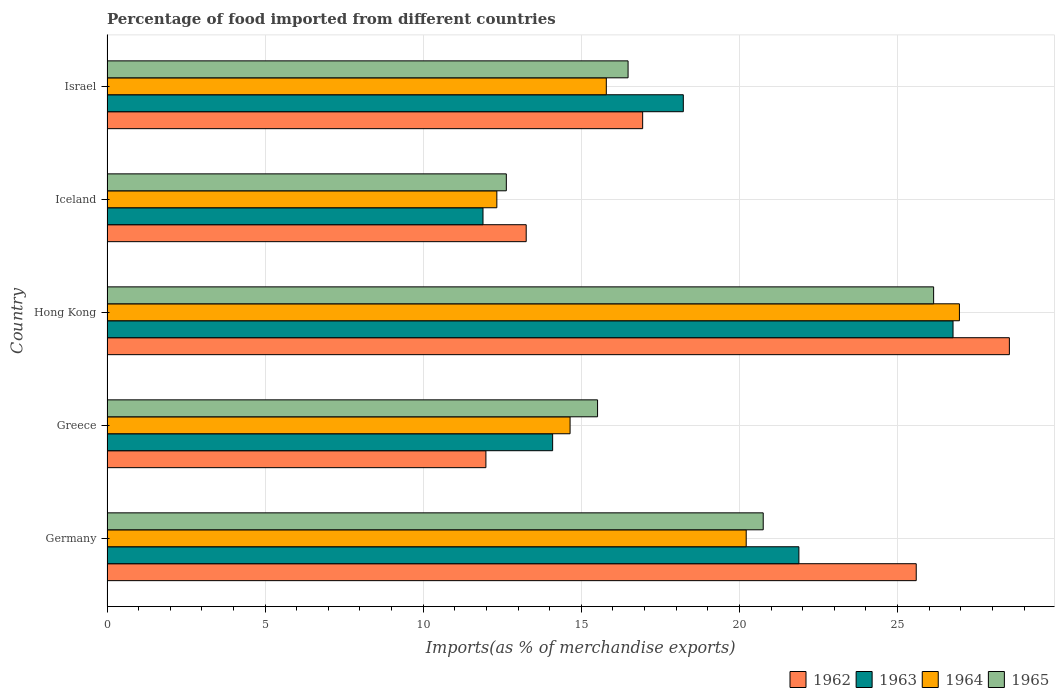How many groups of bars are there?
Offer a very short reply. 5. Are the number of bars per tick equal to the number of legend labels?
Offer a very short reply. Yes. What is the label of the 4th group of bars from the top?
Provide a short and direct response. Greece. In how many cases, is the number of bars for a given country not equal to the number of legend labels?
Ensure brevity in your answer.  0. What is the percentage of imports to different countries in 1964 in Greece?
Keep it short and to the point. 14.64. Across all countries, what is the maximum percentage of imports to different countries in 1962?
Your answer should be very brief. 28.53. Across all countries, what is the minimum percentage of imports to different countries in 1965?
Offer a very short reply. 12.63. In which country was the percentage of imports to different countries in 1964 maximum?
Ensure brevity in your answer.  Hong Kong. In which country was the percentage of imports to different countries in 1965 minimum?
Keep it short and to the point. Iceland. What is the total percentage of imports to different countries in 1962 in the graph?
Provide a succinct answer. 96.3. What is the difference between the percentage of imports to different countries in 1963 in Germany and that in Hong Kong?
Offer a terse response. -4.87. What is the difference between the percentage of imports to different countries in 1963 in Greece and the percentage of imports to different countries in 1965 in Israel?
Make the answer very short. -2.39. What is the average percentage of imports to different countries in 1965 per country?
Provide a short and direct response. 18.3. What is the difference between the percentage of imports to different countries in 1963 and percentage of imports to different countries in 1964 in Hong Kong?
Your answer should be compact. -0.2. What is the ratio of the percentage of imports to different countries in 1964 in Greece to that in Iceland?
Your answer should be very brief. 1.19. What is the difference between the highest and the second highest percentage of imports to different countries in 1963?
Your answer should be compact. 4.87. What is the difference between the highest and the lowest percentage of imports to different countries in 1962?
Your answer should be compact. 16.55. Is the sum of the percentage of imports to different countries in 1962 in Germany and Greece greater than the maximum percentage of imports to different countries in 1964 across all countries?
Ensure brevity in your answer.  Yes. Is it the case that in every country, the sum of the percentage of imports to different countries in 1965 and percentage of imports to different countries in 1963 is greater than the sum of percentage of imports to different countries in 1964 and percentage of imports to different countries in 1962?
Keep it short and to the point. No. What does the 2nd bar from the top in Hong Kong represents?
Offer a very short reply. 1964. What does the 3rd bar from the bottom in Iceland represents?
Offer a terse response. 1964. Are all the bars in the graph horizontal?
Your answer should be very brief. Yes. How many countries are there in the graph?
Offer a very short reply. 5. What is the difference between two consecutive major ticks on the X-axis?
Offer a terse response. 5. Does the graph contain grids?
Give a very brief answer. Yes. How many legend labels are there?
Offer a terse response. 4. What is the title of the graph?
Make the answer very short. Percentage of food imported from different countries. What is the label or title of the X-axis?
Your response must be concise. Imports(as % of merchandise exports). What is the label or title of the Y-axis?
Provide a succinct answer. Country. What is the Imports(as % of merchandise exports) in 1962 in Germany?
Provide a short and direct response. 25.59. What is the Imports(as % of merchandise exports) of 1963 in Germany?
Ensure brevity in your answer.  21.88. What is the Imports(as % of merchandise exports) of 1964 in Germany?
Keep it short and to the point. 20.21. What is the Imports(as % of merchandise exports) of 1965 in Germany?
Offer a terse response. 20.75. What is the Imports(as % of merchandise exports) in 1962 in Greece?
Your answer should be compact. 11.98. What is the Imports(as % of merchandise exports) in 1963 in Greece?
Keep it short and to the point. 14.09. What is the Imports(as % of merchandise exports) in 1964 in Greece?
Your answer should be compact. 14.64. What is the Imports(as % of merchandise exports) in 1965 in Greece?
Your answer should be compact. 15.51. What is the Imports(as % of merchandise exports) of 1962 in Hong Kong?
Provide a succinct answer. 28.53. What is the Imports(as % of merchandise exports) of 1963 in Hong Kong?
Your answer should be very brief. 26.75. What is the Imports(as % of merchandise exports) of 1964 in Hong Kong?
Provide a succinct answer. 26.96. What is the Imports(as % of merchandise exports) in 1965 in Hong Kong?
Your answer should be compact. 26.14. What is the Imports(as % of merchandise exports) of 1962 in Iceland?
Provide a succinct answer. 13.26. What is the Imports(as % of merchandise exports) in 1963 in Iceland?
Ensure brevity in your answer.  11.89. What is the Imports(as % of merchandise exports) of 1964 in Iceland?
Keep it short and to the point. 12.33. What is the Imports(as % of merchandise exports) of 1965 in Iceland?
Offer a very short reply. 12.63. What is the Imports(as % of merchandise exports) in 1962 in Israel?
Your answer should be compact. 16.94. What is the Imports(as % of merchandise exports) of 1963 in Israel?
Offer a very short reply. 18.22. What is the Imports(as % of merchandise exports) in 1964 in Israel?
Give a very brief answer. 15.79. What is the Imports(as % of merchandise exports) of 1965 in Israel?
Your answer should be compact. 16.48. Across all countries, what is the maximum Imports(as % of merchandise exports) of 1962?
Ensure brevity in your answer.  28.53. Across all countries, what is the maximum Imports(as % of merchandise exports) of 1963?
Offer a terse response. 26.75. Across all countries, what is the maximum Imports(as % of merchandise exports) in 1964?
Your answer should be compact. 26.96. Across all countries, what is the maximum Imports(as % of merchandise exports) of 1965?
Offer a very short reply. 26.14. Across all countries, what is the minimum Imports(as % of merchandise exports) in 1962?
Ensure brevity in your answer.  11.98. Across all countries, what is the minimum Imports(as % of merchandise exports) in 1963?
Make the answer very short. 11.89. Across all countries, what is the minimum Imports(as % of merchandise exports) in 1964?
Give a very brief answer. 12.33. Across all countries, what is the minimum Imports(as % of merchandise exports) of 1965?
Ensure brevity in your answer.  12.63. What is the total Imports(as % of merchandise exports) of 1962 in the graph?
Provide a short and direct response. 96.3. What is the total Imports(as % of merchandise exports) of 1963 in the graph?
Provide a short and direct response. 92.84. What is the total Imports(as % of merchandise exports) in 1964 in the graph?
Your answer should be compact. 89.93. What is the total Imports(as % of merchandise exports) in 1965 in the graph?
Provide a succinct answer. 91.51. What is the difference between the Imports(as % of merchandise exports) in 1962 in Germany and that in Greece?
Your answer should be compact. 13.61. What is the difference between the Imports(as % of merchandise exports) of 1963 in Germany and that in Greece?
Offer a very short reply. 7.79. What is the difference between the Imports(as % of merchandise exports) in 1964 in Germany and that in Greece?
Offer a very short reply. 5.57. What is the difference between the Imports(as % of merchandise exports) of 1965 in Germany and that in Greece?
Your answer should be compact. 5.24. What is the difference between the Imports(as % of merchandise exports) of 1962 in Germany and that in Hong Kong?
Provide a succinct answer. -2.95. What is the difference between the Imports(as % of merchandise exports) in 1963 in Germany and that in Hong Kong?
Provide a short and direct response. -4.87. What is the difference between the Imports(as % of merchandise exports) in 1964 in Germany and that in Hong Kong?
Your response must be concise. -6.74. What is the difference between the Imports(as % of merchandise exports) in 1965 in Germany and that in Hong Kong?
Your response must be concise. -5.39. What is the difference between the Imports(as % of merchandise exports) in 1962 in Germany and that in Iceland?
Your response must be concise. 12.33. What is the difference between the Imports(as % of merchandise exports) of 1963 in Germany and that in Iceland?
Offer a very short reply. 9.99. What is the difference between the Imports(as % of merchandise exports) of 1964 in Germany and that in Iceland?
Offer a very short reply. 7.89. What is the difference between the Imports(as % of merchandise exports) in 1965 in Germany and that in Iceland?
Offer a very short reply. 8.12. What is the difference between the Imports(as % of merchandise exports) in 1962 in Germany and that in Israel?
Keep it short and to the point. 8.65. What is the difference between the Imports(as % of merchandise exports) of 1963 in Germany and that in Israel?
Your response must be concise. 3.65. What is the difference between the Imports(as % of merchandise exports) in 1964 in Germany and that in Israel?
Give a very brief answer. 4.42. What is the difference between the Imports(as % of merchandise exports) of 1965 in Germany and that in Israel?
Provide a short and direct response. 4.27. What is the difference between the Imports(as % of merchandise exports) of 1962 in Greece and that in Hong Kong?
Offer a terse response. -16.55. What is the difference between the Imports(as % of merchandise exports) of 1963 in Greece and that in Hong Kong?
Ensure brevity in your answer.  -12.66. What is the difference between the Imports(as % of merchandise exports) in 1964 in Greece and that in Hong Kong?
Provide a short and direct response. -12.31. What is the difference between the Imports(as % of merchandise exports) in 1965 in Greece and that in Hong Kong?
Keep it short and to the point. -10.63. What is the difference between the Imports(as % of merchandise exports) in 1962 in Greece and that in Iceland?
Your answer should be very brief. -1.27. What is the difference between the Imports(as % of merchandise exports) of 1963 in Greece and that in Iceland?
Offer a very short reply. 2.2. What is the difference between the Imports(as % of merchandise exports) in 1964 in Greece and that in Iceland?
Your response must be concise. 2.32. What is the difference between the Imports(as % of merchandise exports) of 1965 in Greece and that in Iceland?
Offer a terse response. 2.88. What is the difference between the Imports(as % of merchandise exports) in 1962 in Greece and that in Israel?
Offer a terse response. -4.96. What is the difference between the Imports(as % of merchandise exports) of 1963 in Greece and that in Israel?
Give a very brief answer. -4.13. What is the difference between the Imports(as % of merchandise exports) of 1964 in Greece and that in Israel?
Provide a succinct answer. -1.15. What is the difference between the Imports(as % of merchandise exports) of 1965 in Greece and that in Israel?
Keep it short and to the point. -0.97. What is the difference between the Imports(as % of merchandise exports) in 1962 in Hong Kong and that in Iceland?
Your answer should be compact. 15.28. What is the difference between the Imports(as % of merchandise exports) of 1963 in Hong Kong and that in Iceland?
Make the answer very short. 14.86. What is the difference between the Imports(as % of merchandise exports) of 1964 in Hong Kong and that in Iceland?
Offer a very short reply. 14.63. What is the difference between the Imports(as % of merchandise exports) in 1965 in Hong Kong and that in Iceland?
Your answer should be compact. 13.51. What is the difference between the Imports(as % of merchandise exports) in 1962 in Hong Kong and that in Israel?
Your response must be concise. 11.6. What is the difference between the Imports(as % of merchandise exports) in 1963 in Hong Kong and that in Israel?
Offer a very short reply. 8.53. What is the difference between the Imports(as % of merchandise exports) of 1964 in Hong Kong and that in Israel?
Offer a very short reply. 11.17. What is the difference between the Imports(as % of merchandise exports) of 1965 in Hong Kong and that in Israel?
Offer a very short reply. 9.66. What is the difference between the Imports(as % of merchandise exports) in 1962 in Iceland and that in Israel?
Offer a terse response. -3.68. What is the difference between the Imports(as % of merchandise exports) of 1963 in Iceland and that in Israel?
Offer a terse response. -6.33. What is the difference between the Imports(as % of merchandise exports) in 1964 in Iceland and that in Israel?
Offer a very short reply. -3.46. What is the difference between the Imports(as % of merchandise exports) in 1965 in Iceland and that in Israel?
Offer a very short reply. -3.85. What is the difference between the Imports(as % of merchandise exports) in 1962 in Germany and the Imports(as % of merchandise exports) in 1963 in Greece?
Make the answer very short. 11.5. What is the difference between the Imports(as % of merchandise exports) in 1962 in Germany and the Imports(as % of merchandise exports) in 1964 in Greece?
Your response must be concise. 10.95. What is the difference between the Imports(as % of merchandise exports) in 1962 in Germany and the Imports(as % of merchandise exports) in 1965 in Greece?
Provide a short and direct response. 10.08. What is the difference between the Imports(as % of merchandise exports) of 1963 in Germany and the Imports(as % of merchandise exports) of 1964 in Greece?
Provide a short and direct response. 7.24. What is the difference between the Imports(as % of merchandise exports) of 1963 in Germany and the Imports(as % of merchandise exports) of 1965 in Greece?
Offer a terse response. 6.37. What is the difference between the Imports(as % of merchandise exports) in 1964 in Germany and the Imports(as % of merchandise exports) in 1965 in Greece?
Keep it short and to the point. 4.7. What is the difference between the Imports(as % of merchandise exports) in 1962 in Germany and the Imports(as % of merchandise exports) in 1963 in Hong Kong?
Provide a succinct answer. -1.16. What is the difference between the Imports(as % of merchandise exports) of 1962 in Germany and the Imports(as % of merchandise exports) of 1964 in Hong Kong?
Offer a terse response. -1.37. What is the difference between the Imports(as % of merchandise exports) in 1962 in Germany and the Imports(as % of merchandise exports) in 1965 in Hong Kong?
Give a very brief answer. -0.55. What is the difference between the Imports(as % of merchandise exports) in 1963 in Germany and the Imports(as % of merchandise exports) in 1964 in Hong Kong?
Keep it short and to the point. -5.08. What is the difference between the Imports(as % of merchandise exports) in 1963 in Germany and the Imports(as % of merchandise exports) in 1965 in Hong Kong?
Offer a very short reply. -4.26. What is the difference between the Imports(as % of merchandise exports) in 1964 in Germany and the Imports(as % of merchandise exports) in 1965 in Hong Kong?
Make the answer very short. -5.93. What is the difference between the Imports(as % of merchandise exports) in 1962 in Germany and the Imports(as % of merchandise exports) in 1963 in Iceland?
Provide a succinct answer. 13.7. What is the difference between the Imports(as % of merchandise exports) of 1962 in Germany and the Imports(as % of merchandise exports) of 1964 in Iceland?
Ensure brevity in your answer.  13.26. What is the difference between the Imports(as % of merchandise exports) in 1962 in Germany and the Imports(as % of merchandise exports) in 1965 in Iceland?
Offer a very short reply. 12.96. What is the difference between the Imports(as % of merchandise exports) of 1963 in Germany and the Imports(as % of merchandise exports) of 1964 in Iceland?
Your answer should be compact. 9.55. What is the difference between the Imports(as % of merchandise exports) in 1963 in Germany and the Imports(as % of merchandise exports) in 1965 in Iceland?
Ensure brevity in your answer.  9.25. What is the difference between the Imports(as % of merchandise exports) of 1964 in Germany and the Imports(as % of merchandise exports) of 1965 in Iceland?
Provide a short and direct response. 7.59. What is the difference between the Imports(as % of merchandise exports) in 1962 in Germany and the Imports(as % of merchandise exports) in 1963 in Israel?
Provide a succinct answer. 7.37. What is the difference between the Imports(as % of merchandise exports) of 1962 in Germany and the Imports(as % of merchandise exports) of 1964 in Israel?
Keep it short and to the point. 9.8. What is the difference between the Imports(as % of merchandise exports) of 1962 in Germany and the Imports(as % of merchandise exports) of 1965 in Israel?
Your answer should be compact. 9.11. What is the difference between the Imports(as % of merchandise exports) of 1963 in Germany and the Imports(as % of merchandise exports) of 1964 in Israel?
Offer a terse response. 6.09. What is the difference between the Imports(as % of merchandise exports) in 1963 in Germany and the Imports(as % of merchandise exports) in 1965 in Israel?
Your answer should be compact. 5.4. What is the difference between the Imports(as % of merchandise exports) in 1964 in Germany and the Imports(as % of merchandise exports) in 1965 in Israel?
Offer a very short reply. 3.74. What is the difference between the Imports(as % of merchandise exports) in 1962 in Greece and the Imports(as % of merchandise exports) in 1963 in Hong Kong?
Keep it short and to the point. -14.77. What is the difference between the Imports(as % of merchandise exports) of 1962 in Greece and the Imports(as % of merchandise exports) of 1964 in Hong Kong?
Your answer should be very brief. -14.97. What is the difference between the Imports(as % of merchandise exports) in 1962 in Greece and the Imports(as % of merchandise exports) in 1965 in Hong Kong?
Provide a succinct answer. -14.16. What is the difference between the Imports(as % of merchandise exports) of 1963 in Greece and the Imports(as % of merchandise exports) of 1964 in Hong Kong?
Your answer should be very brief. -12.86. What is the difference between the Imports(as % of merchandise exports) in 1963 in Greece and the Imports(as % of merchandise exports) in 1965 in Hong Kong?
Give a very brief answer. -12.05. What is the difference between the Imports(as % of merchandise exports) in 1964 in Greece and the Imports(as % of merchandise exports) in 1965 in Hong Kong?
Provide a succinct answer. -11.5. What is the difference between the Imports(as % of merchandise exports) in 1962 in Greece and the Imports(as % of merchandise exports) in 1963 in Iceland?
Ensure brevity in your answer.  0.09. What is the difference between the Imports(as % of merchandise exports) of 1962 in Greece and the Imports(as % of merchandise exports) of 1964 in Iceland?
Make the answer very short. -0.35. What is the difference between the Imports(as % of merchandise exports) in 1962 in Greece and the Imports(as % of merchandise exports) in 1965 in Iceland?
Provide a short and direct response. -0.65. What is the difference between the Imports(as % of merchandise exports) in 1963 in Greece and the Imports(as % of merchandise exports) in 1964 in Iceland?
Offer a very short reply. 1.76. What is the difference between the Imports(as % of merchandise exports) of 1963 in Greece and the Imports(as % of merchandise exports) of 1965 in Iceland?
Provide a succinct answer. 1.46. What is the difference between the Imports(as % of merchandise exports) of 1964 in Greece and the Imports(as % of merchandise exports) of 1965 in Iceland?
Your answer should be compact. 2.02. What is the difference between the Imports(as % of merchandise exports) of 1962 in Greece and the Imports(as % of merchandise exports) of 1963 in Israel?
Your answer should be very brief. -6.24. What is the difference between the Imports(as % of merchandise exports) of 1962 in Greece and the Imports(as % of merchandise exports) of 1964 in Israel?
Your answer should be compact. -3.81. What is the difference between the Imports(as % of merchandise exports) in 1962 in Greece and the Imports(as % of merchandise exports) in 1965 in Israel?
Offer a very short reply. -4.5. What is the difference between the Imports(as % of merchandise exports) in 1963 in Greece and the Imports(as % of merchandise exports) in 1964 in Israel?
Offer a terse response. -1.7. What is the difference between the Imports(as % of merchandise exports) in 1963 in Greece and the Imports(as % of merchandise exports) in 1965 in Israel?
Your answer should be very brief. -2.39. What is the difference between the Imports(as % of merchandise exports) in 1964 in Greece and the Imports(as % of merchandise exports) in 1965 in Israel?
Offer a terse response. -1.83. What is the difference between the Imports(as % of merchandise exports) of 1962 in Hong Kong and the Imports(as % of merchandise exports) of 1963 in Iceland?
Offer a very short reply. 16.65. What is the difference between the Imports(as % of merchandise exports) in 1962 in Hong Kong and the Imports(as % of merchandise exports) in 1964 in Iceland?
Make the answer very short. 16.21. What is the difference between the Imports(as % of merchandise exports) in 1962 in Hong Kong and the Imports(as % of merchandise exports) in 1965 in Iceland?
Keep it short and to the point. 15.91. What is the difference between the Imports(as % of merchandise exports) in 1963 in Hong Kong and the Imports(as % of merchandise exports) in 1964 in Iceland?
Keep it short and to the point. 14.43. What is the difference between the Imports(as % of merchandise exports) of 1963 in Hong Kong and the Imports(as % of merchandise exports) of 1965 in Iceland?
Provide a succinct answer. 14.13. What is the difference between the Imports(as % of merchandise exports) in 1964 in Hong Kong and the Imports(as % of merchandise exports) in 1965 in Iceland?
Provide a short and direct response. 14.33. What is the difference between the Imports(as % of merchandise exports) in 1962 in Hong Kong and the Imports(as % of merchandise exports) in 1963 in Israel?
Keep it short and to the point. 10.31. What is the difference between the Imports(as % of merchandise exports) in 1962 in Hong Kong and the Imports(as % of merchandise exports) in 1964 in Israel?
Give a very brief answer. 12.75. What is the difference between the Imports(as % of merchandise exports) of 1962 in Hong Kong and the Imports(as % of merchandise exports) of 1965 in Israel?
Offer a terse response. 12.06. What is the difference between the Imports(as % of merchandise exports) in 1963 in Hong Kong and the Imports(as % of merchandise exports) in 1964 in Israel?
Your answer should be compact. 10.96. What is the difference between the Imports(as % of merchandise exports) in 1963 in Hong Kong and the Imports(as % of merchandise exports) in 1965 in Israel?
Offer a terse response. 10.28. What is the difference between the Imports(as % of merchandise exports) in 1964 in Hong Kong and the Imports(as % of merchandise exports) in 1965 in Israel?
Ensure brevity in your answer.  10.48. What is the difference between the Imports(as % of merchandise exports) in 1962 in Iceland and the Imports(as % of merchandise exports) in 1963 in Israel?
Offer a very short reply. -4.97. What is the difference between the Imports(as % of merchandise exports) in 1962 in Iceland and the Imports(as % of merchandise exports) in 1964 in Israel?
Offer a terse response. -2.53. What is the difference between the Imports(as % of merchandise exports) of 1962 in Iceland and the Imports(as % of merchandise exports) of 1965 in Israel?
Offer a terse response. -3.22. What is the difference between the Imports(as % of merchandise exports) of 1963 in Iceland and the Imports(as % of merchandise exports) of 1964 in Israel?
Keep it short and to the point. -3.9. What is the difference between the Imports(as % of merchandise exports) in 1963 in Iceland and the Imports(as % of merchandise exports) in 1965 in Israel?
Your answer should be very brief. -4.59. What is the difference between the Imports(as % of merchandise exports) in 1964 in Iceland and the Imports(as % of merchandise exports) in 1965 in Israel?
Provide a succinct answer. -4.15. What is the average Imports(as % of merchandise exports) in 1962 per country?
Ensure brevity in your answer.  19.26. What is the average Imports(as % of merchandise exports) of 1963 per country?
Your response must be concise. 18.57. What is the average Imports(as % of merchandise exports) in 1964 per country?
Your response must be concise. 17.99. What is the average Imports(as % of merchandise exports) of 1965 per country?
Offer a terse response. 18.3. What is the difference between the Imports(as % of merchandise exports) in 1962 and Imports(as % of merchandise exports) in 1963 in Germany?
Your answer should be very brief. 3.71. What is the difference between the Imports(as % of merchandise exports) in 1962 and Imports(as % of merchandise exports) in 1964 in Germany?
Provide a short and direct response. 5.38. What is the difference between the Imports(as % of merchandise exports) in 1962 and Imports(as % of merchandise exports) in 1965 in Germany?
Offer a terse response. 4.84. What is the difference between the Imports(as % of merchandise exports) in 1963 and Imports(as % of merchandise exports) in 1964 in Germany?
Your answer should be very brief. 1.67. What is the difference between the Imports(as % of merchandise exports) in 1963 and Imports(as % of merchandise exports) in 1965 in Germany?
Ensure brevity in your answer.  1.13. What is the difference between the Imports(as % of merchandise exports) in 1964 and Imports(as % of merchandise exports) in 1965 in Germany?
Your response must be concise. -0.54. What is the difference between the Imports(as % of merchandise exports) in 1962 and Imports(as % of merchandise exports) in 1963 in Greece?
Provide a short and direct response. -2.11. What is the difference between the Imports(as % of merchandise exports) in 1962 and Imports(as % of merchandise exports) in 1964 in Greece?
Offer a very short reply. -2.66. What is the difference between the Imports(as % of merchandise exports) of 1962 and Imports(as % of merchandise exports) of 1965 in Greece?
Keep it short and to the point. -3.53. What is the difference between the Imports(as % of merchandise exports) of 1963 and Imports(as % of merchandise exports) of 1964 in Greece?
Make the answer very short. -0.55. What is the difference between the Imports(as % of merchandise exports) in 1963 and Imports(as % of merchandise exports) in 1965 in Greece?
Your answer should be compact. -1.42. What is the difference between the Imports(as % of merchandise exports) of 1964 and Imports(as % of merchandise exports) of 1965 in Greece?
Keep it short and to the point. -0.87. What is the difference between the Imports(as % of merchandise exports) in 1962 and Imports(as % of merchandise exports) in 1963 in Hong Kong?
Your answer should be compact. 1.78. What is the difference between the Imports(as % of merchandise exports) of 1962 and Imports(as % of merchandise exports) of 1964 in Hong Kong?
Ensure brevity in your answer.  1.58. What is the difference between the Imports(as % of merchandise exports) of 1962 and Imports(as % of merchandise exports) of 1965 in Hong Kong?
Make the answer very short. 2.4. What is the difference between the Imports(as % of merchandise exports) of 1963 and Imports(as % of merchandise exports) of 1964 in Hong Kong?
Your answer should be compact. -0.2. What is the difference between the Imports(as % of merchandise exports) of 1963 and Imports(as % of merchandise exports) of 1965 in Hong Kong?
Make the answer very short. 0.61. What is the difference between the Imports(as % of merchandise exports) of 1964 and Imports(as % of merchandise exports) of 1965 in Hong Kong?
Keep it short and to the point. 0.82. What is the difference between the Imports(as % of merchandise exports) in 1962 and Imports(as % of merchandise exports) in 1963 in Iceland?
Offer a terse response. 1.37. What is the difference between the Imports(as % of merchandise exports) of 1962 and Imports(as % of merchandise exports) of 1964 in Iceland?
Give a very brief answer. 0.93. What is the difference between the Imports(as % of merchandise exports) of 1962 and Imports(as % of merchandise exports) of 1965 in Iceland?
Provide a short and direct response. 0.63. What is the difference between the Imports(as % of merchandise exports) in 1963 and Imports(as % of merchandise exports) in 1964 in Iceland?
Provide a short and direct response. -0.44. What is the difference between the Imports(as % of merchandise exports) of 1963 and Imports(as % of merchandise exports) of 1965 in Iceland?
Your answer should be compact. -0.74. What is the difference between the Imports(as % of merchandise exports) of 1964 and Imports(as % of merchandise exports) of 1965 in Iceland?
Keep it short and to the point. -0.3. What is the difference between the Imports(as % of merchandise exports) in 1962 and Imports(as % of merchandise exports) in 1963 in Israel?
Your response must be concise. -1.29. What is the difference between the Imports(as % of merchandise exports) of 1962 and Imports(as % of merchandise exports) of 1964 in Israel?
Your response must be concise. 1.15. What is the difference between the Imports(as % of merchandise exports) of 1962 and Imports(as % of merchandise exports) of 1965 in Israel?
Make the answer very short. 0.46. What is the difference between the Imports(as % of merchandise exports) in 1963 and Imports(as % of merchandise exports) in 1964 in Israel?
Provide a succinct answer. 2.43. What is the difference between the Imports(as % of merchandise exports) of 1963 and Imports(as % of merchandise exports) of 1965 in Israel?
Provide a short and direct response. 1.75. What is the difference between the Imports(as % of merchandise exports) of 1964 and Imports(as % of merchandise exports) of 1965 in Israel?
Make the answer very short. -0.69. What is the ratio of the Imports(as % of merchandise exports) of 1962 in Germany to that in Greece?
Make the answer very short. 2.14. What is the ratio of the Imports(as % of merchandise exports) in 1963 in Germany to that in Greece?
Ensure brevity in your answer.  1.55. What is the ratio of the Imports(as % of merchandise exports) of 1964 in Germany to that in Greece?
Your response must be concise. 1.38. What is the ratio of the Imports(as % of merchandise exports) of 1965 in Germany to that in Greece?
Offer a terse response. 1.34. What is the ratio of the Imports(as % of merchandise exports) of 1962 in Germany to that in Hong Kong?
Your answer should be very brief. 0.9. What is the ratio of the Imports(as % of merchandise exports) in 1963 in Germany to that in Hong Kong?
Your answer should be compact. 0.82. What is the ratio of the Imports(as % of merchandise exports) of 1964 in Germany to that in Hong Kong?
Your answer should be very brief. 0.75. What is the ratio of the Imports(as % of merchandise exports) in 1965 in Germany to that in Hong Kong?
Provide a short and direct response. 0.79. What is the ratio of the Imports(as % of merchandise exports) in 1962 in Germany to that in Iceland?
Offer a terse response. 1.93. What is the ratio of the Imports(as % of merchandise exports) of 1963 in Germany to that in Iceland?
Keep it short and to the point. 1.84. What is the ratio of the Imports(as % of merchandise exports) in 1964 in Germany to that in Iceland?
Ensure brevity in your answer.  1.64. What is the ratio of the Imports(as % of merchandise exports) in 1965 in Germany to that in Iceland?
Make the answer very short. 1.64. What is the ratio of the Imports(as % of merchandise exports) of 1962 in Germany to that in Israel?
Provide a short and direct response. 1.51. What is the ratio of the Imports(as % of merchandise exports) in 1963 in Germany to that in Israel?
Your response must be concise. 1.2. What is the ratio of the Imports(as % of merchandise exports) of 1964 in Germany to that in Israel?
Offer a very short reply. 1.28. What is the ratio of the Imports(as % of merchandise exports) of 1965 in Germany to that in Israel?
Make the answer very short. 1.26. What is the ratio of the Imports(as % of merchandise exports) in 1962 in Greece to that in Hong Kong?
Your answer should be compact. 0.42. What is the ratio of the Imports(as % of merchandise exports) in 1963 in Greece to that in Hong Kong?
Provide a short and direct response. 0.53. What is the ratio of the Imports(as % of merchandise exports) in 1964 in Greece to that in Hong Kong?
Provide a succinct answer. 0.54. What is the ratio of the Imports(as % of merchandise exports) of 1965 in Greece to that in Hong Kong?
Provide a short and direct response. 0.59. What is the ratio of the Imports(as % of merchandise exports) in 1962 in Greece to that in Iceland?
Your response must be concise. 0.9. What is the ratio of the Imports(as % of merchandise exports) of 1963 in Greece to that in Iceland?
Your answer should be compact. 1.19. What is the ratio of the Imports(as % of merchandise exports) of 1964 in Greece to that in Iceland?
Keep it short and to the point. 1.19. What is the ratio of the Imports(as % of merchandise exports) in 1965 in Greece to that in Iceland?
Ensure brevity in your answer.  1.23. What is the ratio of the Imports(as % of merchandise exports) of 1962 in Greece to that in Israel?
Ensure brevity in your answer.  0.71. What is the ratio of the Imports(as % of merchandise exports) of 1963 in Greece to that in Israel?
Your response must be concise. 0.77. What is the ratio of the Imports(as % of merchandise exports) in 1964 in Greece to that in Israel?
Your answer should be very brief. 0.93. What is the ratio of the Imports(as % of merchandise exports) of 1965 in Greece to that in Israel?
Provide a short and direct response. 0.94. What is the ratio of the Imports(as % of merchandise exports) in 1962 in Hong Kong to that in Iceland?
Make the answer very short. 2.15. What is the ratio of the Imports(as % of merchandise exports) in 1963 in Hong Kong to that in Iceland?
Your response must be concise. 2.25. What is the ratio of the Imports(as % of merchandise exports) of 1964 in Hong Kong to that in Iceland?
Offer a very short reply. 2.19. What is the ratio of the Imports(as % of merchandise exports) in 1965 in Hong Kong to that in Iceland?
Make the answer very short. 2.07. What is the ratio of the Imports(as % of merchandise exports) in 1962 in Hong Kong to that in Israel?
Provide a succinct answer. 1.68. What is the ratio of the Imports(as % of merchandise exports) of 1963 in Hong Kong to that in Israel?
Offer a very short reply. 1.47. What is the ratio of the Imports(as % of merchandise exports) in 1964 in Hong Kong to that in Israel?
Keep it short and to the point. 1.71. What is the ratio of the Imports(as % of merchandise exports) in 1965 in Hong Kong to that in Israel?
Give a very brief answer. 1.59. What is the ratio of the Imports(as % of merchandise exports) in 1962 in Iceland to that in Israel?
Your answer should be compact. 0.78. What is the ratio of the Imports(as % of merchandise exports) in 1963 in Iceland to that in Israel?
Make the answer very short. 0.65. What is the ratio of the Imports(as % of merchandise exports) of 1964 in Iceland to that in Israel?
Provide a short and direct response. 0.78. What is the ratio of the Imports(as % of merchandise exports) of 1965 in Iceland to that in Israel?
Provide a succinct answer. 0.77. What is the difference between the highest and the second highest Imports(as % of merchandise exports) of 1962?
Your answer should be very brief. 2.95. What is the difference between the highest and the second highest Imports(as % of merchandise exports) in 1963?
Make the answer very short. 4.87. What is the difference between the highest and the second highest Imports(as % of merchandise exports) of 1964?
Offer a terse response. 6.74. What is the difference between the highest and the second highest Imports(as % of merchandise exports) in 1965?
Provide a succinct answer. 5.39. What is the difference between the highest and the lowest Imports(as % of merchandise exports) of 1962?
Provide a succinct answer. 16.55. What is the difference between the highest and the lowest Imports(as % of merchandise exports) of 1963?
Your response must be concise. 14.86. What is the difference between the highest and the lowest Imports(as % of merchandise exports) of 1964?
Offer a terse response. 14.63. What is the difference between the highest and the lowest Imports(as % of merchandise exports) in 1965?
Your answer should be very brief. 13.51. 